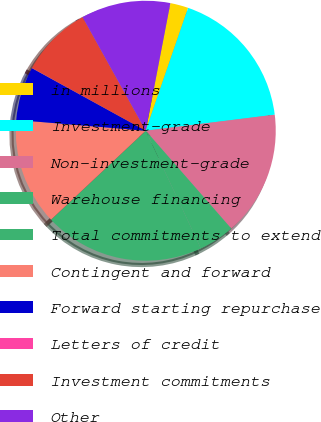Convert chart. <chart><loc_0><loc_0><loc_500><loc_500><pie_chart><fcel>in millions<fcel>Investment-grade<fcel>Non-investment-grade<fcel>Warehouse financing<fcel>Total commitments to extend<fcel>Contingent and forward<fcel>Forward starting repurchase<fcel>Letters of credit<fcel>Investment commitments<fcel>Other<nl><fcel>2.25%<fcel>17.75%<fcel>15.54%<fcel>4.46%<fcel>19.97%<fcel>13.32%<fcel>6.68%<fcel>0.03%<fcel>8.89%<fcel>11.11%<nl></chart> 